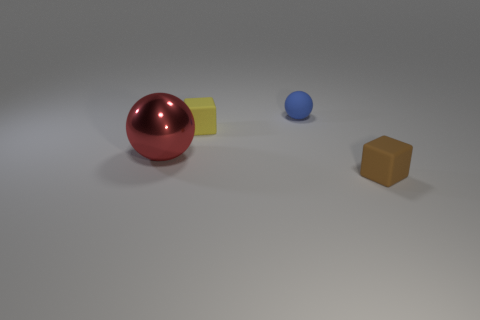Does the small object that is in front of the small yellow thing have the same material as the small ball that is to the right of the red ball?
Give a very brief answer. Yes. What color is the other cube that is the same size as the brown matte block?
Provide a succinct answer. Yellow. Is there any other thing that has the same color as the large object?
Keep it short and to the point. No. What size is the sphere in front of the matte object that is behind the tiny rubber cube behind the brown rubber thing?
Ensure brevity in your answer.  Large. The thing that is both to the right of the large red metal sphere and in front of the yellow thing is what color?
Your response must be concise. Brown. There is a yellow rubber object left of the small blue thing; what size is it?
Your response must be concise. Small. How many tiny yellow objects are the same material as the tiny yellow block?
Offer a very short reply. 0. Is the shape of the tiny yellow matte object on the left side of the brown rubber block the same as  the brown object?
Provide a short and direct response. Yes. The cube that is made of the same material as the yellow thing is what color?
Make the answer very short. Brown. There is a block that is to the left of the brown rubber thing that is in front of the yellow matte cube; are there any small brown rubber objects that are in front of it?
Make the answer very short. Yes. 